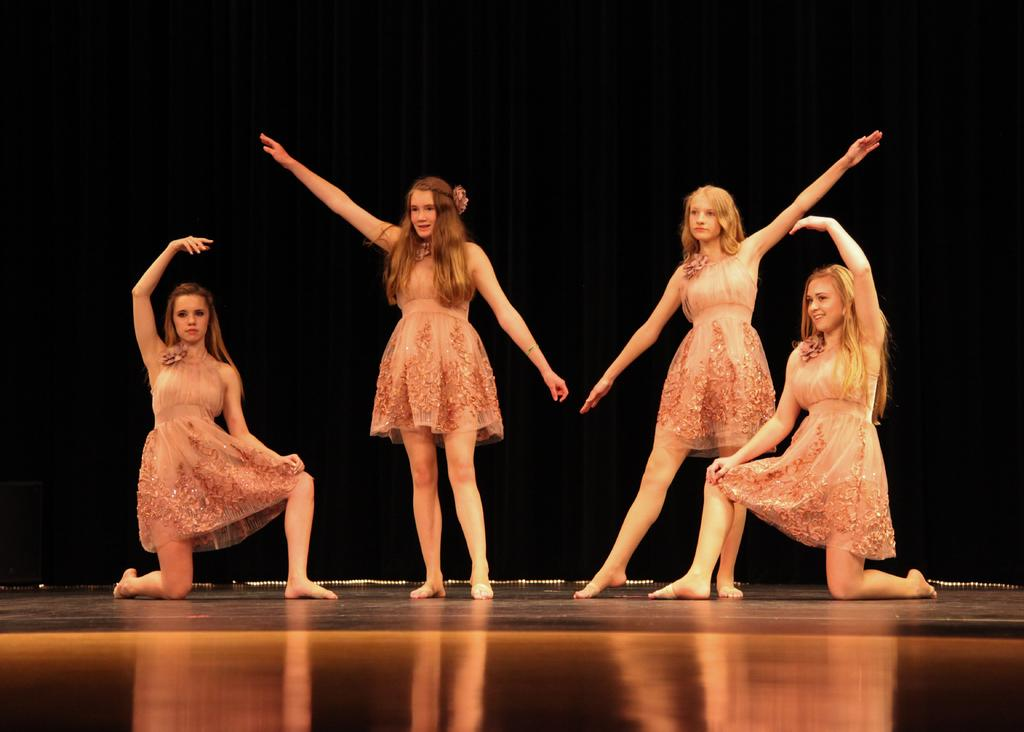Who is present in the image? There are men in the image. What are the men doing in the image? Some of the men are standing on a dais. What can be seen in the background of the image? The background of the image is black. What type of pies are being served on the dais in the image? There are no pies present in the image; the men are standing on the dais. How can the men in the image be helped to get off the dais? There is no indication that the men need help to get off the dais, and we cannot assume their intentions or needs based on the image alone. 